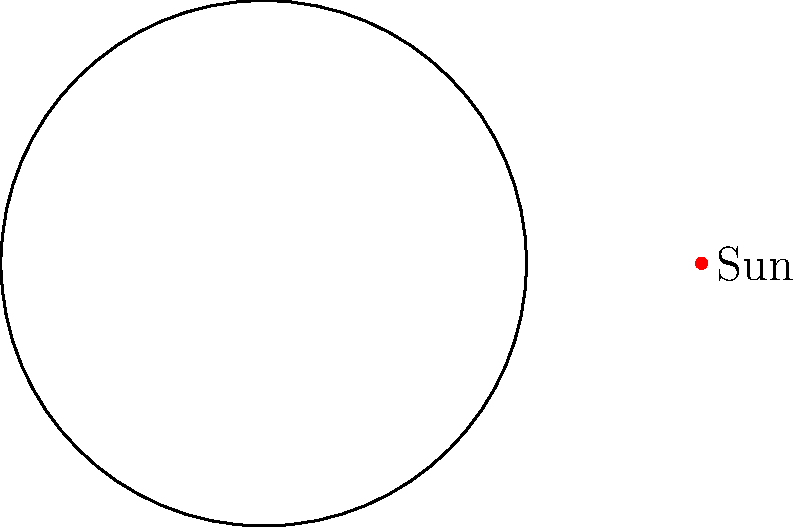As you blend your musical tea creations, consider the Earth's annual journey around the Sun. How does the tilt of Earth's axis, which remains fixed at approximately 23.5 degrees, contribute to the changing seasons we experience throughout the year? 1. Earth's axis tilt: The Earth's axis is tilted at approximately 23.5 degrees relative to its orbital plane around the Sun. This tilt remains constant throughout the year.

2. Orbital motion: As the Earth orbits the Sun, it completes one revolution in about 365.25 days.

3. Changing orientation: Due to the fixed tilt and orbital motion, different parts of Earth face the Sun more directly at different times of the year.

4. Seasonal variations:
   a. Summer (Northern Hemisphere): The North Pole is tilted towards the Sun, resulting in longer days and more direct sunlight.
   b. Winter (Northern Hemisphere): The North Pole is tilted away from the Sun, leading to shorter days and less direct sunlight.
   c. Spring and Autumn: The Earth's axis is tilted neither towards nor away from the Sun, resulting in roughly equal day and night lengths.

5. Hemisphere differences: When it's summer in the Northern Hemisphere, it's winter in the Southern Hemisphere, and vice versa.

6. Solar energy distribution: The tilt affects the angle at which sunlight hits different parts of Earth, influencing the amount of solar energy received and thus the temperature and climate.

7. Day length variation: The tilt causes variations in day length throughout the year, with longer days in summer and shorter days in winter for locations away from the equator.

This cyclical pattern of seasons, caused by Earth's axial tilt and orbital motion, provides a natural rhythm that could inspire various tea blends, much like different music genres evoke distinct moods and experiences.
Answer: Earth's 23.5° axial tilt causes varying sunlight exposure as it orbits the Sun, creating seasons. 